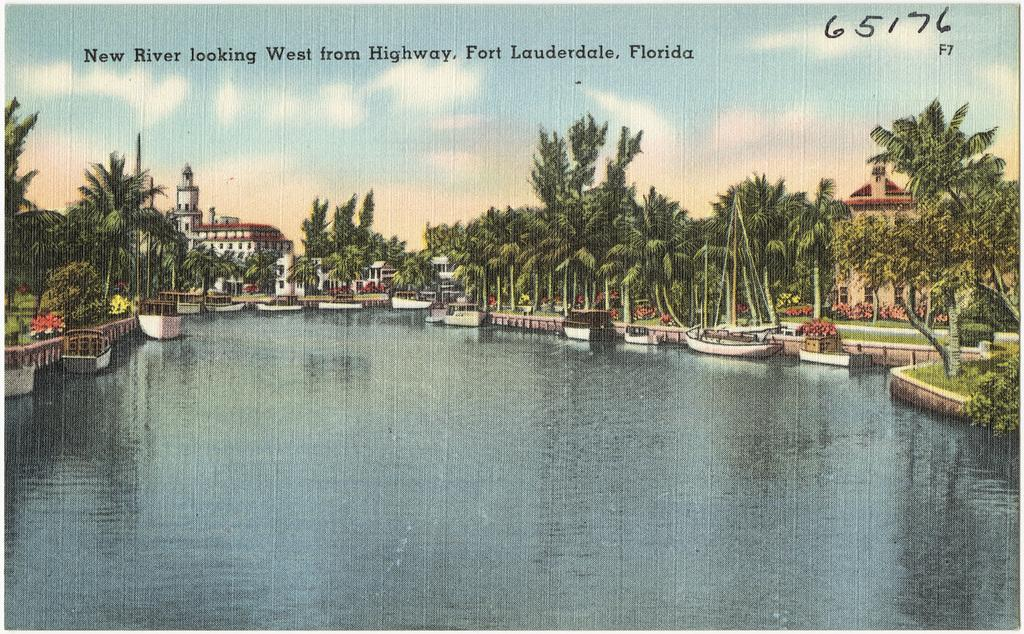What body of water is visible in the image? There is a lake in the image. What is on the lake in the image? There are boats on the lake. What type of vegetation can be seen in the image? There are trees visible in the image. What type of structures can be seen in the image? There are buildings in the image. What is visible in the sky in the image? Clouds are present in the sky. What is written at the top of the image? There is some text at the top of the image. What type of rod is used to catch fish in the lake in the image? There is no rod visible in the image, and it is not mentioned that fishing is taking place. What color are the trousers worn by the trees in the image? Trees do not wear trousers; they are plants and do not have clothing. What sound does the bell make when it rings in the image? There is no bell present in the image. 